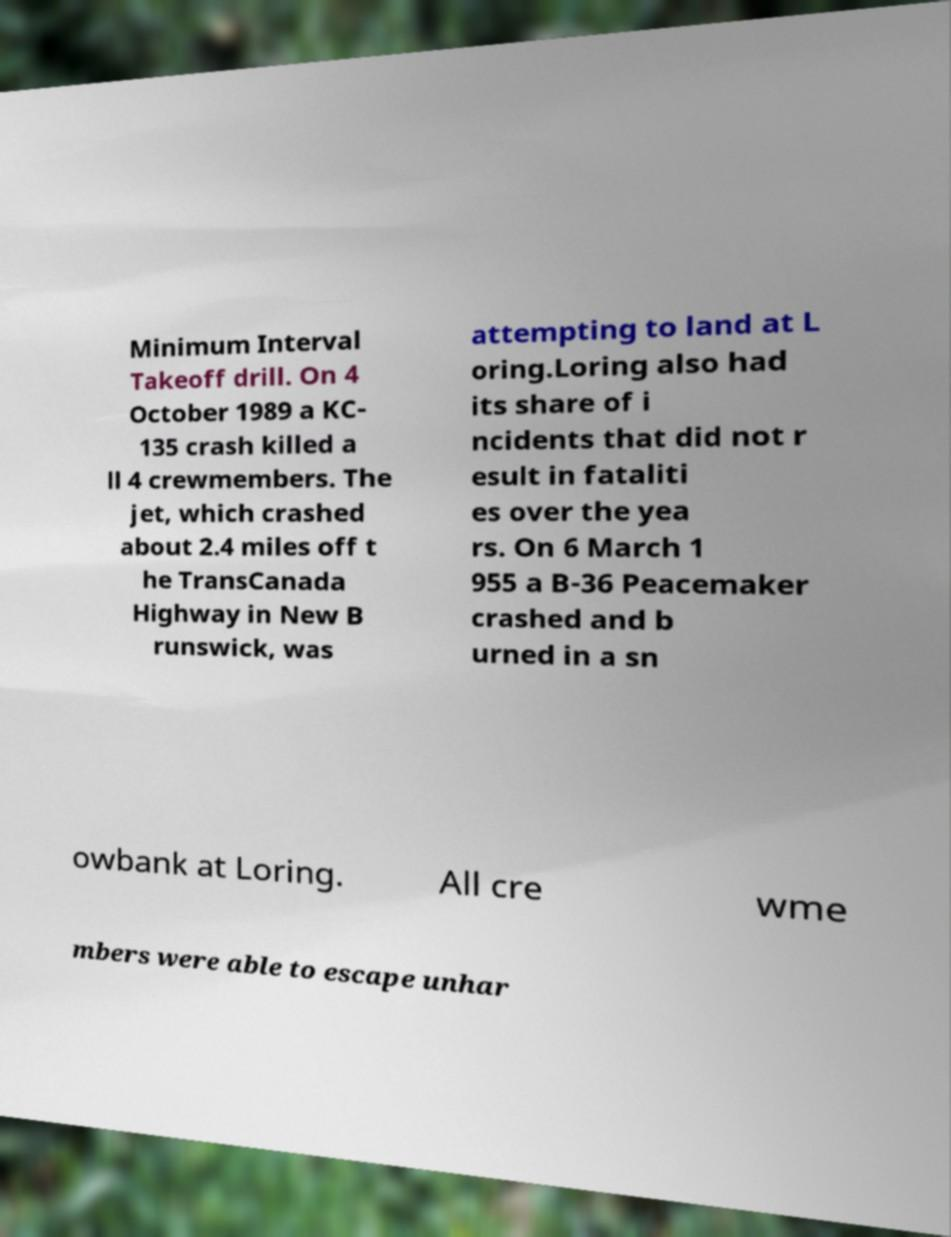I need the written content from this picture converted into text. Can you do that? Minimum Interval Takeoff drill. On 4 October 1989 a KC- 135 crash killed a ll 4 crewmembers. The jet, which crashed about 2.4 miles off t he TransCanada Highway in New B runswick, was attempting to land at L oring.Loring also had its share of i ncidents that did not r esult in fataliti es over the yea rs. On 6 March 1 955 a B-36 Peacemaker crashed and b urned in a sn owbank at Loring. All cre wme mbers were able to escape unhar 